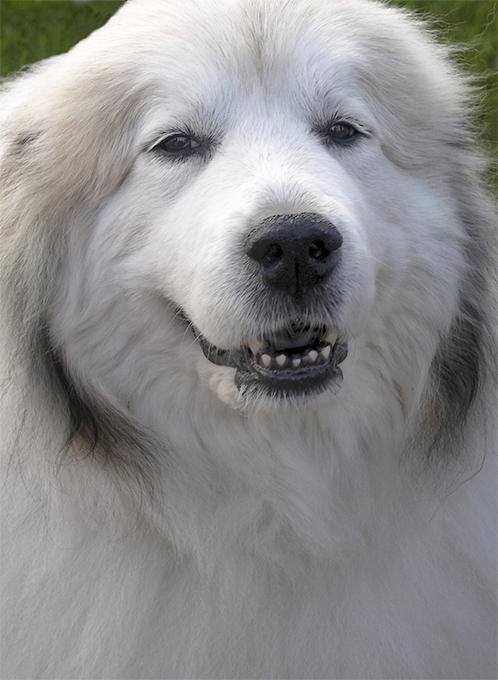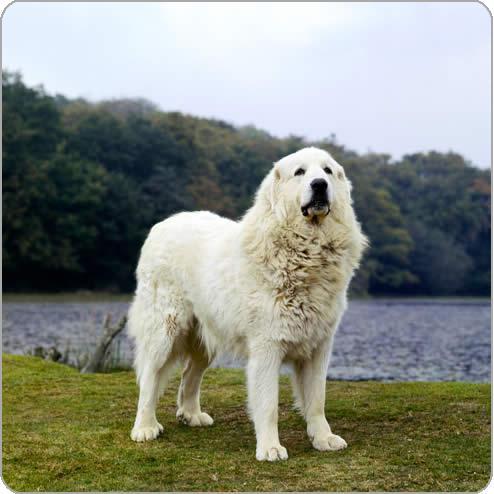The first image is the image on the left, the second image is the image on the right. Assess this claim about the two images: "One of the dogs has its tongue visible.". Correct or not? Answer yes or no. No. 